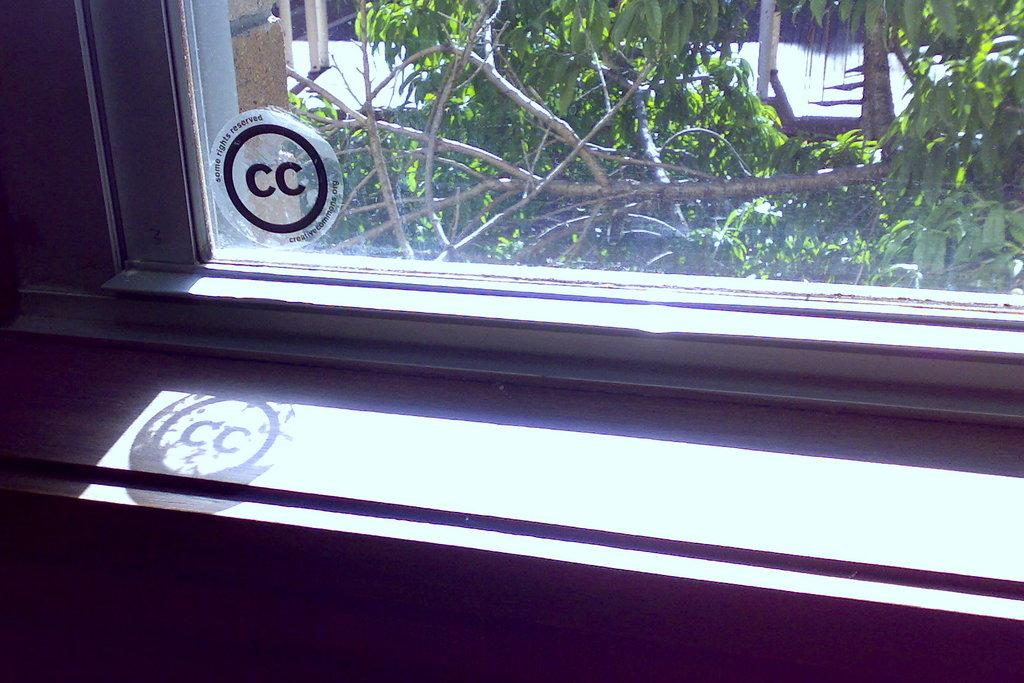What type of structure is present in the image? There is a glass window in the image. What can be seen through the window? Tree branches and leaves are visible outside the window. What type of doctor is standing in front of the window in the image? There is no doctor present in the image. The image only features a glass window with tree branches and leaves visible outside. 